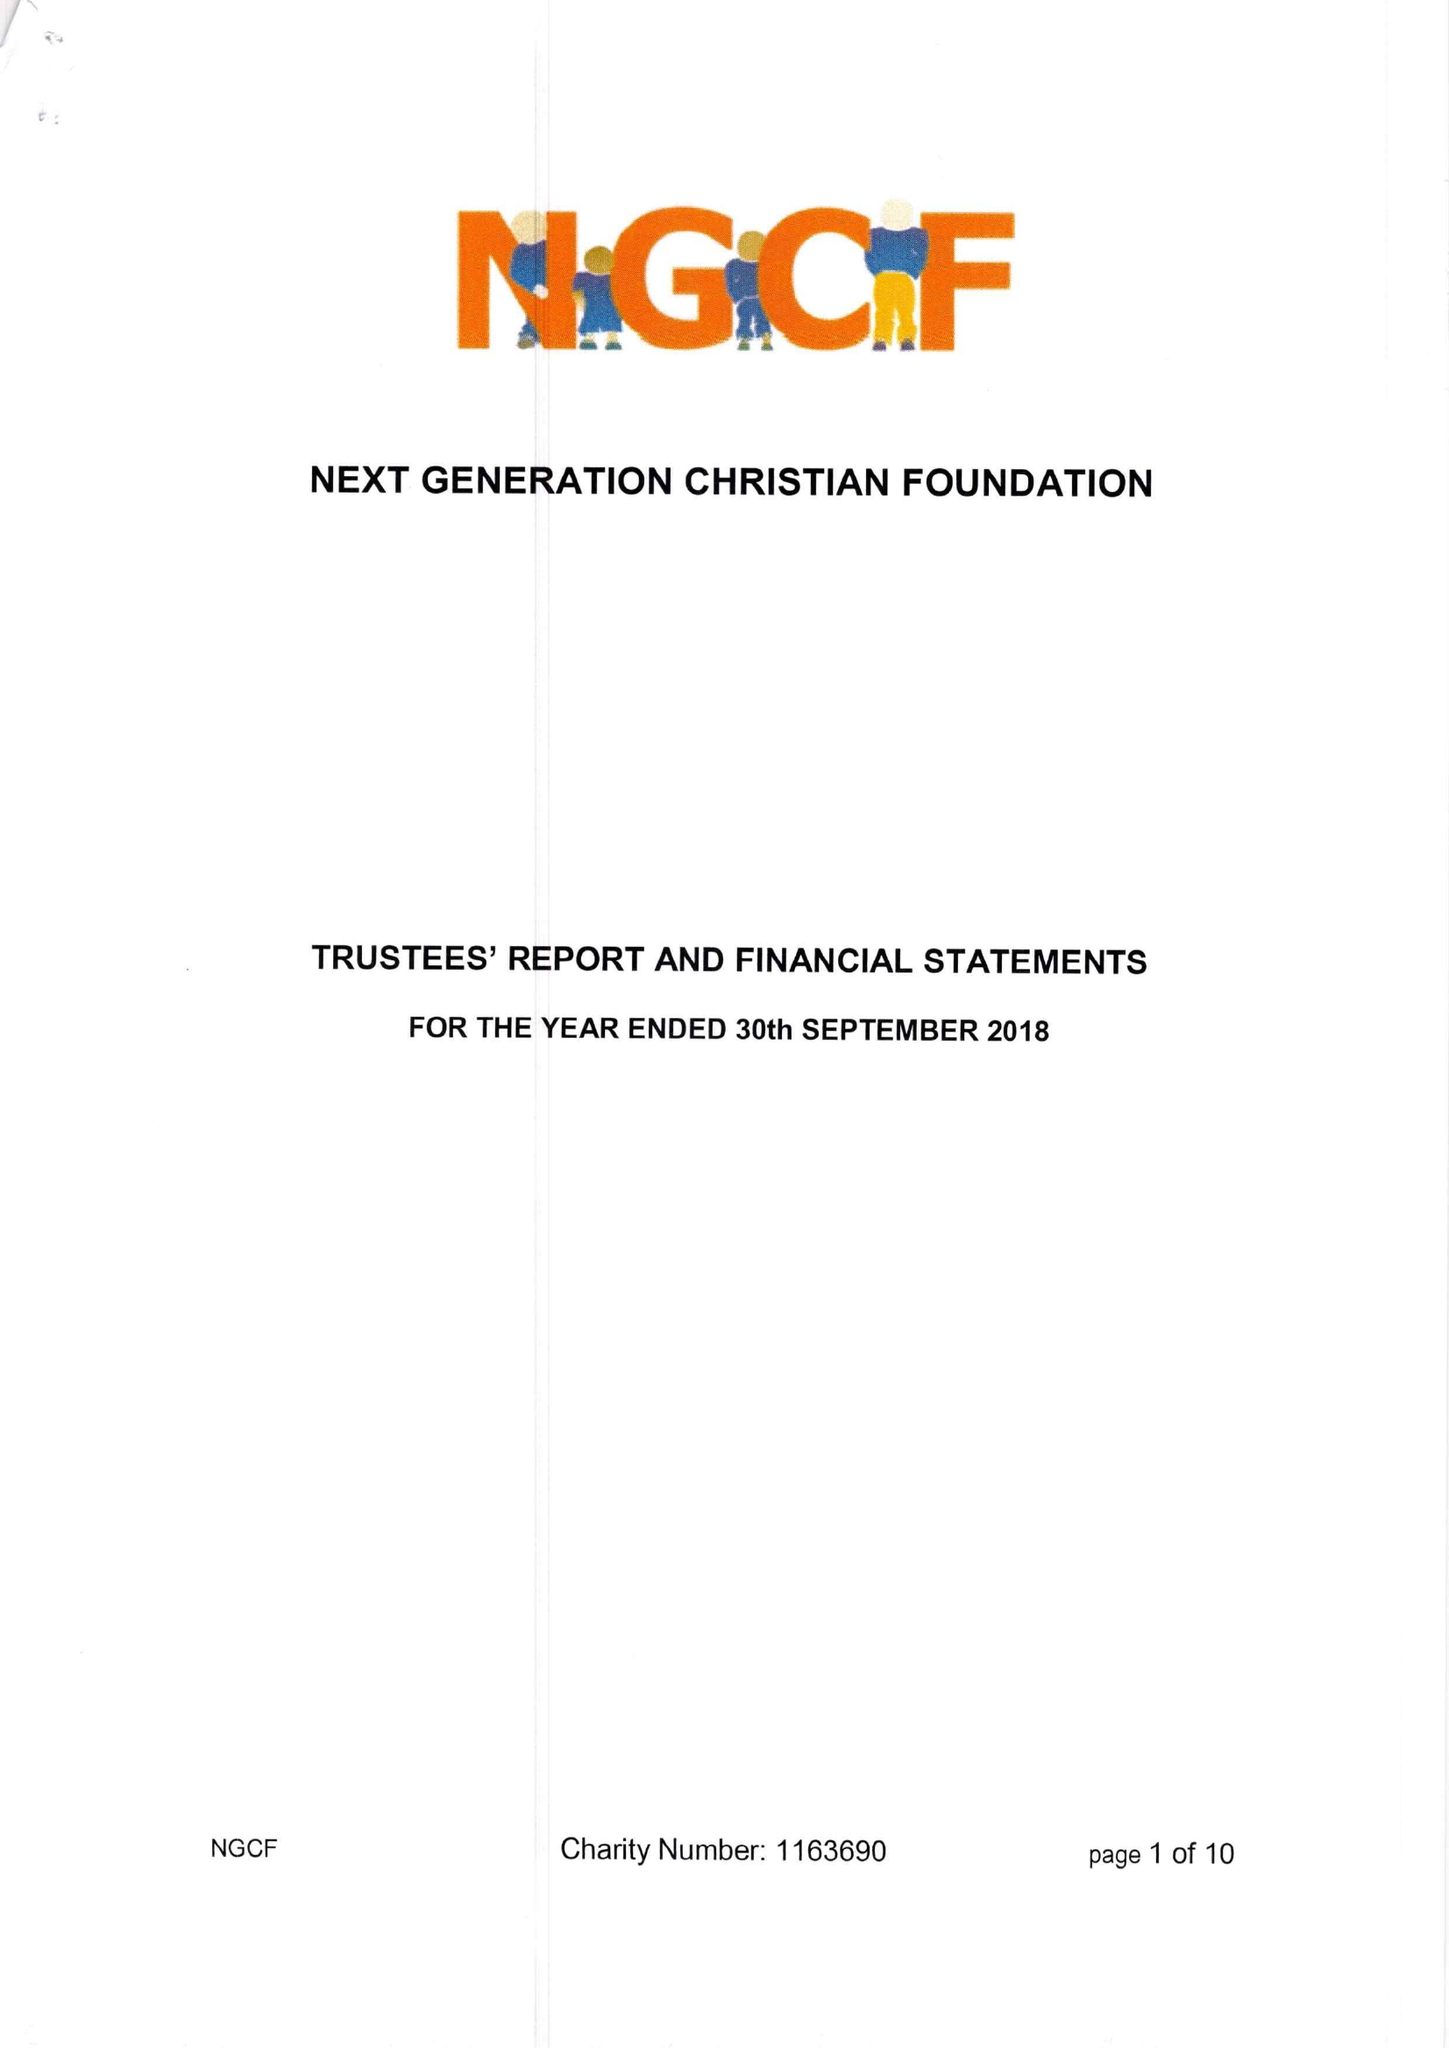What is the value for the income_annually_in_british_pounds?
Answer the question using a single word or phrase. 37023.00 